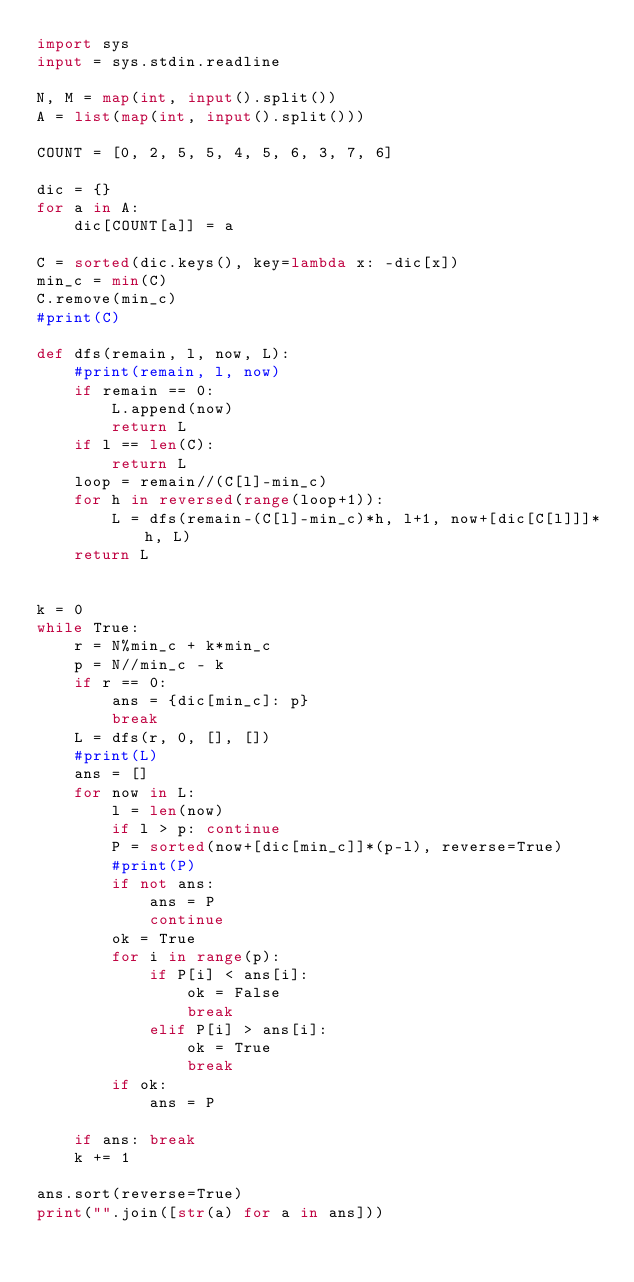Convert code to text. <code><loc_0><loc_0><loc_500><loc_500><_Python_>import sys
input = sys.stdin.readline

N, M = map(int, input().split())
A = list(map(int, input().split()))

COUNT = [0, 2, 5, 5, 4, 5, 6, 3, 7, 6]

dic = {}
for a in A:
    dic[COUNT[a]] = a

C = sorted(dic.keys(), key=lambda x: -dic[x])
min_c = min(C)
C.remove(min_c)
#print(C)

def dfs(remain, l, now, L):
    #print(remain, l, now)
    if remain == 0:
        L.append(now)
        return L
    if l == len(C):
        return L
    loop = remain//(C[l]-min_c)
    for h in reversed(range(loop+1)):
        L = dfs(remain-(C[l]-min_c)*h, l+1, now+[dic[C[l]]]*h, L)
    return L


k = 0
while True:
    r = N%min_c + k*min_c
    p = N//min_c - k
    if r == 0:
        ans = {dic[min_c]: p}
        break
    L = dfs(r, 0, [], [])
    #print(L)
    ans = []
    for now in L:
        l = len(now)
        if l > p: continue
        P = sorted(now+[dic[min_c]]*(p-l), reverse=True)
        #print(P)
        if not ans:
            ans = P
            continue
        ok = True
        for i in range(p):
            if P[i] < ans[i]:
                ok = False
                break
            elif P[i] > ans[i]:
                ok = True
                break
        if ok:
            ans = P

    if ans: break
    k += 1

ans.sort(reverse=True)
print("".join([str(a) for a in ans]))</code> 